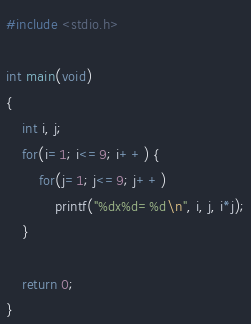<code> <loc_0><loc_0><loc_500><loc_500><_C_>#include <stdio.h>

int main(void)
{
	int i, j;
	for(i=1; i<=9; i++) {
		for(j=1; j<=9; j++)
			printf("%dx%d=%d\n", i, j, i*j);
	}
	
	return 0;
}
</code> 